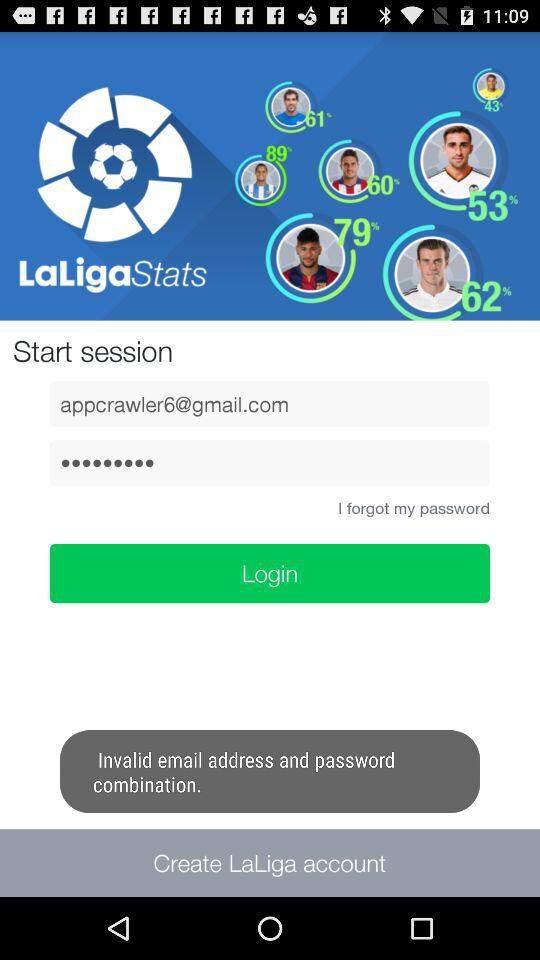What is the entered password?
When the provided information is insufficient, respond with <no answer>. <no answer> 